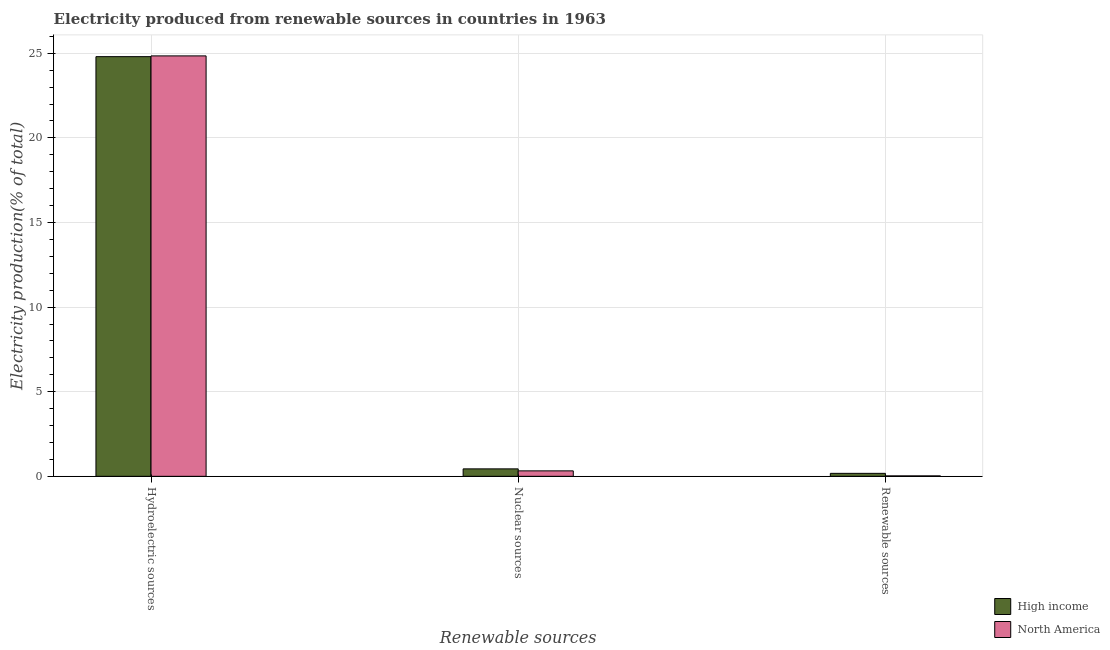Are the number of bars per tick equal to the number of legend labels?
Ensure brevity in your answer.  Yes. Are the number of bars on each tick of the X-axis equal?
Offer a very short reply. Yes. How many bars are there on the 1st tick from the left?
Your response must be concise. 2. How many bars are there on the 1st tick from the right?
Offer a very short reply. 2. What is the label of the 2nd group of bars from the left?
Offer a very short reply. Nuclear sources. What is the percentage of electricity produced by renewable sources in North America?
Provide a short and direct response. 0.03. Across all countries, what is the maximum percentage of electricity produced by hydroelectric sources?
Your answer should be very brief. 24.84. Across all countries, what is the minimum percentage of electricity produced by nuclear sources?
Provide a succinct answer. 0.32. In which country was the percentage of electricity produced by renewable sources maximum?
Keep it short and to the point. High income. What is the total percentage of electricity produced by hydroelectric sources in the graph?
Your answer should be compact. 49.65. What is the difference between the percentage of electricity produced by nuclear sources in High income and that in North America?
Keep it short and to the point. 0.12. What is the difference between the percentage of electricity produced by renewable sources in High income and the percentage of electricity produced by nuclear sources in North America?
Keep it short and to the point. -0.15. What is the average percentage of electricity produced by renewable sources per country?
Make the answer very short. 0.1. What is the difference between the percentage of electricity produced by nuclear sources and percentage of electricity produced by hydroelectric sources in High income?
Make the answer very short. -24.36. In how many countries, is the percentage of electricity produced by hydroelectric sources greater than 24 %?
Ensure brevity in your answer.  2. What is the ratio of the percentage of electricity produced by hydroelectric sources in North America to that in High income?
Keep it short and to the point. 1. Is the difference between the percentage of electricity produced by nuclear sources in North America and High income greater than the difference between the percentage of electricity produced by hydroelectric sources in North America and High income?
Provide a short and direct response. No. What is the difference between the highest and the second highest percentage of electricity produced by renewable sources?
Give a very brief answer. 0.15. What is the difference between the highest and the lowest percentage of electricity produced by nuclear sources?
Your answer should be very brief. 0.12. In how many countries, is the percentage of electricity produced by renewable sources greater than the average percentage of electricity produced by renewable sources taken over all countries?
Offer a terse response. 1. What does the 2nd bar from the left in Renewable sources represents?
Ensure brevity in your answer.  North America. What does the 2nd bar from the right in Nuclear sources represents?
Ensure brevity in your answer.  High income. What is the difference between two consecutive major ticks on the Y-axis?
Give a very brief answer. 5. Does the graph contain any zero values?
Ensure brevity in your answer.  No. How many legend labels are there?
Your answer should be compact. 2. How are the legend labels stacked?
Provide a short and direct response. Vertical. What is the title of the graph?
Ensure brevity in your answer.  Electricity produced from renewable sources in countries in 1963. What is the label or title of the X-axis?
Offer a terse response. Renewable sources. What is the Electricity production(% of total) of High income in Hydroelectric sources?
Keep it short and to the point. 24.8. What is the Electricity production(% of total) in North America in Hydroelectric sources?
Provide a succinct answer. 24.84. What is the Electricity production(% of total) of High income in Nuclear sources?
Your answer should be very brief. 0.44. What is the Electricity production(% of total) of North America in Nuclear sources?
Offer a terse response. 0.32. What is the Electricity production(% of total) in High income in Renewable sources?
Offer a very short reply. 0.18. What is the Electricity production(% of total) in North America in Renewable sources?
Your answer should be very brief. 0.03. Across all Renewable sources, what is the maximum Electricity production(% of total) in High income?
Your answer should be compact. 24.8. Across all Renewable sources, what is the maximum Electricity production(% of total) of North America?
Your answer should be very brief. 24.84. Across all Renewable sources, what is the minimum Electricity production(% of total) of High income?
Provide a succinct answer. 0.18. Across all Renewable sources, what is the minimum Electricity production(% of total) in North America?
Ensure brevity in your answer.  0.03. What is the total Electricity production(% of total) in High income in the graph?
Provide a succinct answer. 25.42. What is the total Electricity production(% of total) in North America in the graph?
Your answer should be compact. 25.19. What is the difference between the Electricity production(% of total) of High income in Hydroelectric sources and that in Nuclear sources?
Keep it short and to the point. 24.36. What is the difference between the Electricity production(% of total) of North America in Hydroelectric sources and that in Nuclear sources?
Give a very brief answer. 24.52. What is the difference between the Electricity production(% of total) of High income in Hydroelectric sources and that in Renewable sources?
Ensure brevity in your answer.  24.63. What is the difference between the Electricity production(% of total) in North America in Hydroelectric sources and that in Renewable sources?
Offer a very short reply. 24.82. What is the difference between the Electricity production(% of total) of High income in Nuclear sources and that in Renewable sources?
Make the answer very short. 0.27. What is the difference between the Electricity production(% of total) of North America in Nuclear sources and that in Renewable sources?
Your response must be concise. 0.3. What is the difference between the Electricity production(% of total) in High income in Hydroelectric sources and the Electricity production(% of total) in North America in Nuclear sources?
Ensure brevity in your answer.  24.48. What is the difference between the Electricity production(% of total) in High income in Hydroelectric sources and the Electricity production(% of total) in North America in Renewable sources?
Provide a short and direct response. 24.77. What is the difference between the Electricity production(% of total) in High income in Nuclear sources and the Electricity production(% of total) in North America in Renewable sources?
Ensure brevity in your answer.  0.41. What is the average Electricity production(% of total) of High income per Renewable sources?
Offer a very short reply. 8.47. What is the average Electricity production(% of total) of North America per Renewable sources?
Make the answer very short. 8.4. What is the difference between the Electricity production(% of total) of High income and Electricity production(% of total) of North America in Hydroelectric sources?
Offer a terse response. -0.04. What is the difference between the Electricity production(% of total) in High income and Electricity production(% of total) in North America in Nuclear sources?
Make the answer very short. 0.12. What is the difference between the Electricity production(% of total) of High income and Electricity production(% of total) of North America in Renewable sources?
Your response must be concise. 0.15. What is the ratio of the Electricity production(% of total) in High income in Hydroelectric sources to that in Nuclear sources?
Provide a succinct answer. 56.29. What is the ratio of the Electricity production(% of total) in North America in Hydroelectric sources to that in Nuclear sources?
Ensure brevity in your answer.  77.18. What is the ratio of the Electricity production(% of total) in High income in Hydroelectric sources to that in Renewable sources?
Your answer should be very brief. 141.25. What is the ratio of the Electricity production(% of total) of North America in Hydroelectric sources to that in Renewable sources?
Provide a succinct answer. 952.6. What is the ratio of the Electricity production(% of total) in High income in Nuclear sources to that in Renewable sources?
Offer a terse response. 2.51. What is the ratio of the Electricity production(% of total) in North America in Nuclear sources to that in Renewable sources?
Ensure brevity in your answer.  12.34. What is the difference between the highest and the second highest Electricity production(% of total) in High income?
Offer a terse response. 24.36. What is the difference between the highest and the second highest Electricity production(% of total) in North America?
Provide a short and direct response. 24.52. What is the difference between the highest and the lowest Electricity production(% of total) of High income?
Provide a succinct answer. 24.63. What is the difference between the highest and the lowest Electricity production(% of total) in North America?
Provide a short and direct response. 24.82. 